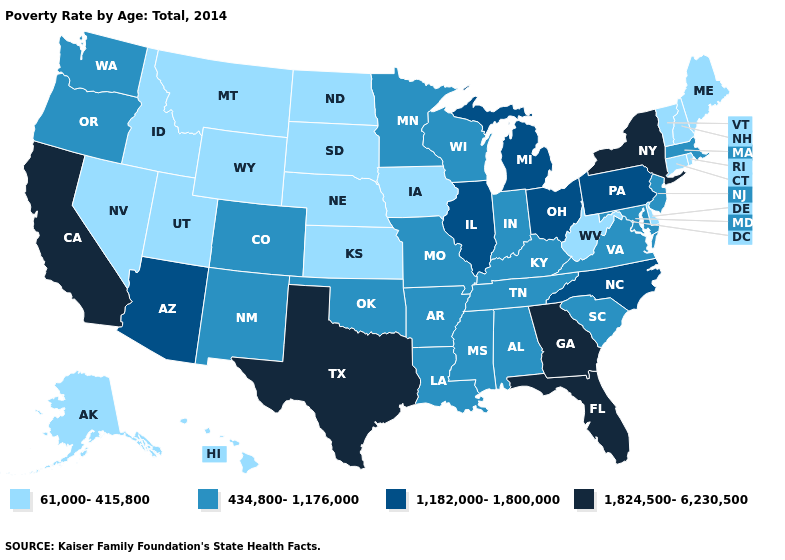How many symbols are there in the legend?
Concise answer only. 4. Which states have the lowest value in the USA?
Be succinct. Alaska, Connecticut, Delaware, Hawaii, Idaho, Iowa, Kansas, Maine, Montana, Nebraska, Nevada, New Hampshire, North Dakota, Rhode Island, South Dakota, Utah, Vermont, West Virginia, Wyoming. Among the states that border Oklahoma , which have the lowest value?
Write a very short answer. Kansas. What is the lowest value in the USA?
Keep it brief. 61,000-415,800. Does Michigan have the highest value in the MidWest?
Answer briefly. Yes. What is the highest value in the West ?
Concise answer only. 1,824,500-6,230,500. Which states hav the highest value in the South?
Answer briefly. Florida, Georgia, Texas. Among the states that border Nevada , which have the lowest value?
Concise answer only. Idaho, Utah. Which states have the lowest value in the USA?
Write a very short answer. Alaska, Connecticut, Delaware, Hawaii, Idaho, Iowa, Kansas, Maine, Montana, Nebraska, Nevada, New Hampshire, North Dakota, Rhode Island, South Dakota, Utah, Vermont, West Virginia, Wyoming. Does Georgia have the lowest value in the South?
Be succinct. No. Which states hav the highest value in the South?
Concise answer only. Florida, Georgia, Texas. What is the lowest value in states that border Colorado?
Give a very brief answer. 61,000-415,800. Name the states that have a value in the range 1,182,000-1,800,000?
Short answer required. Arizona, Illinois, Michigan, North Carolina, Ohio, Pennsylvania. What is the value of New Jersey?
Quick response, please. 434,800-1,176,000. Name the states that have a value in the range 61,000-415,800?
Quick response, please. Alaska, Connecticut, Delaware, Hawaii, Idaho, Iowa, Kansas, Maine, Montana, Nebraska, Nevada, New Hampshire, North Dakota, Rhode Island, South Dakota, Utah, Vermont, West Virginia, Wyoming. 